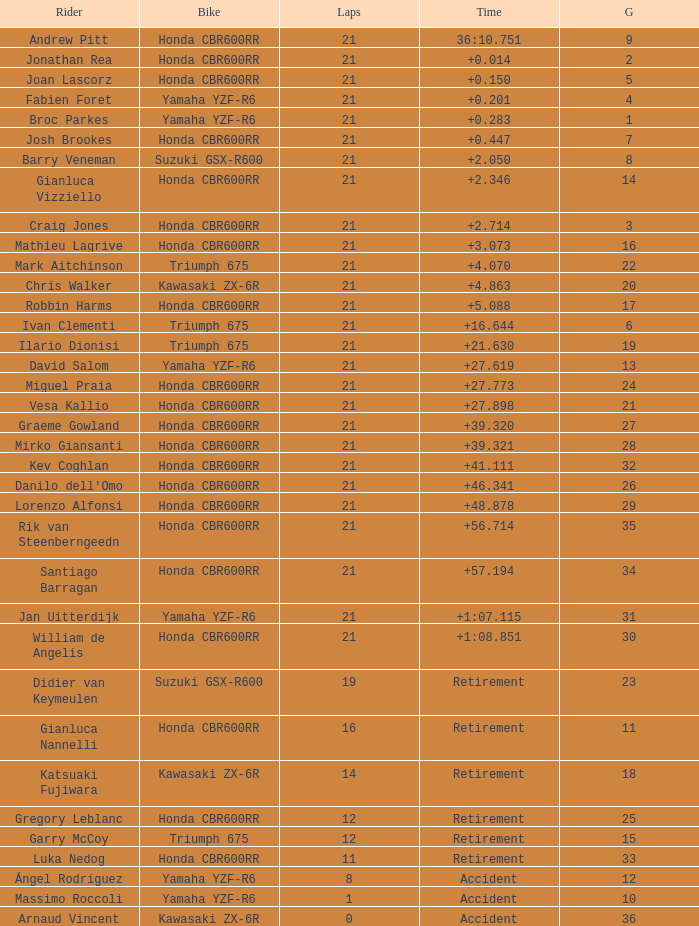283? 1.0. 